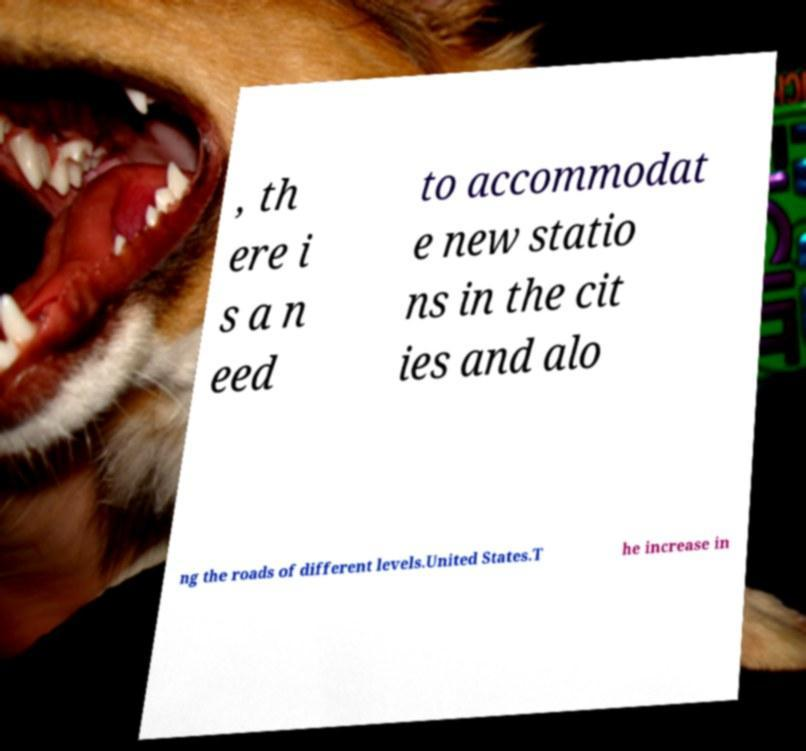There's text embedded in this image that I need extracted. Can you transcribe it verbatim? , th ere i s a n eed to accommodat e new statio ns in the cit ies and alo ng the roads of different levels.United States.T he increase in 